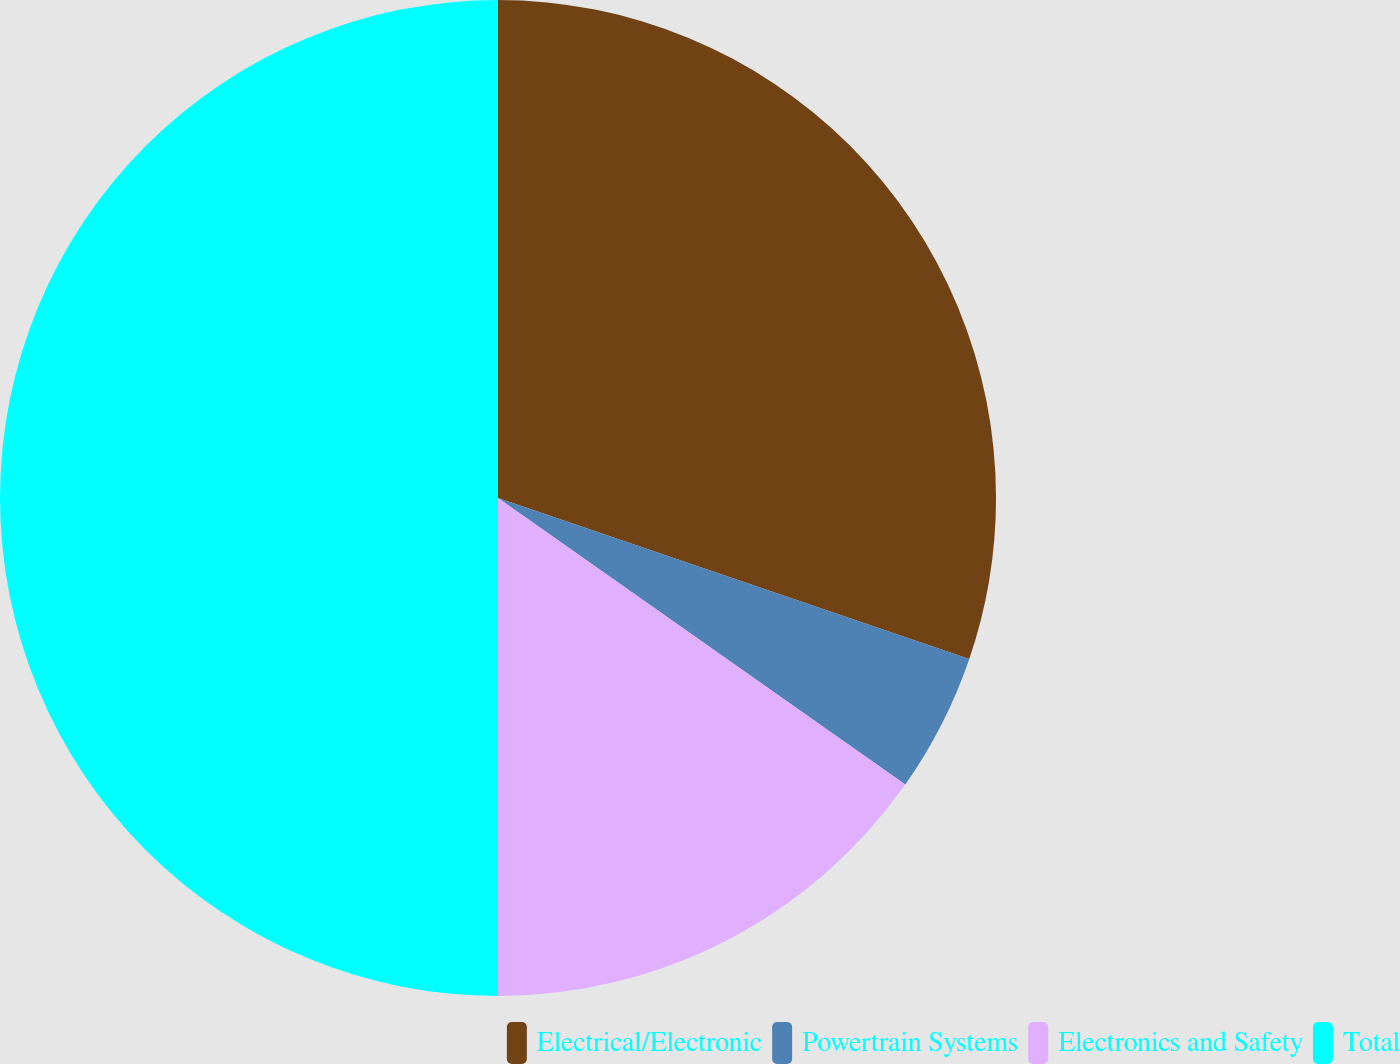<chart> <loc_0><loc_0><loc_500><loc_500><pie_chart><fcel>Electrical/Electronic<fcel>Powertrain Systems<fcel>Electronics and Safety<fcel>Total<nl><fcel>30.24%<fcel>4.52%<fcel>15.24%<fcel>50.0%<nl></chart> 